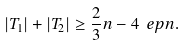<formula> <loc_0><loc_0><loc_500><loc_500>| T _ { 1 } | + | T _ { 2 } | \geq \frac { 2 } { 3 } n - 4 \ e p n .</formula> 